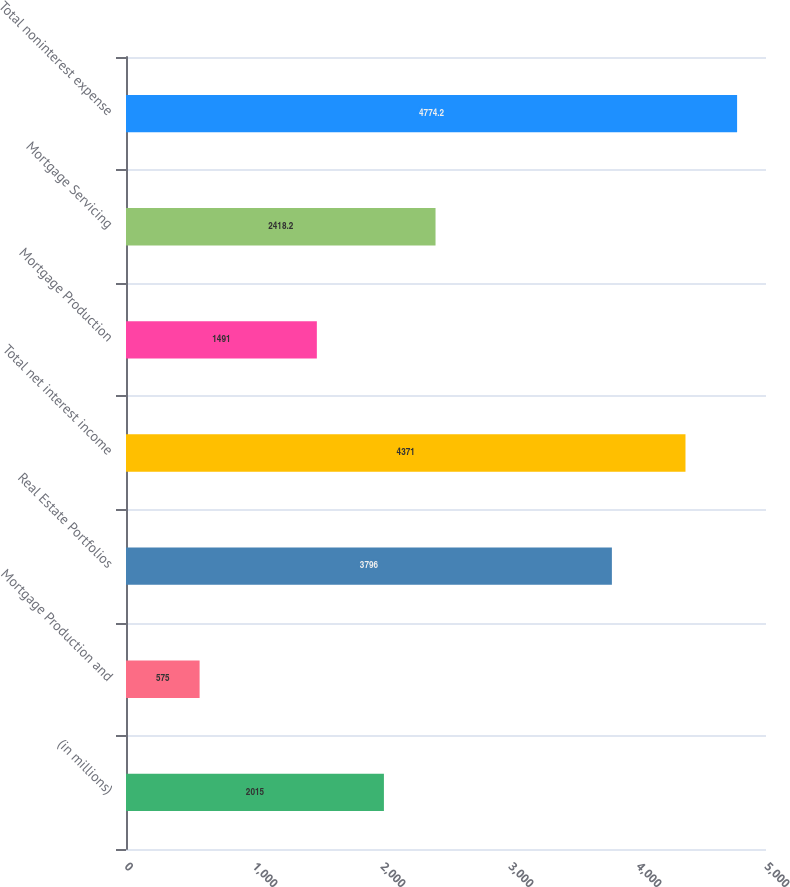Convert chart. <chart><loc_0><loc_0><loc_500><loc_500><bar_chart><fcel>(in millions)<fcel>Mortgage Production and<fcel>Real Estate Portfolios<fcel>Total net interest income<fcel>Mortgage Production<fcel>Mortgage Servicing<fcel>Total noninterest expense<nl><fcel>2015<fcel>575<fcel>3796<fcel>4371<fcel>1491<fcel>2418.2<fcel>4774.2<nl></chart> 